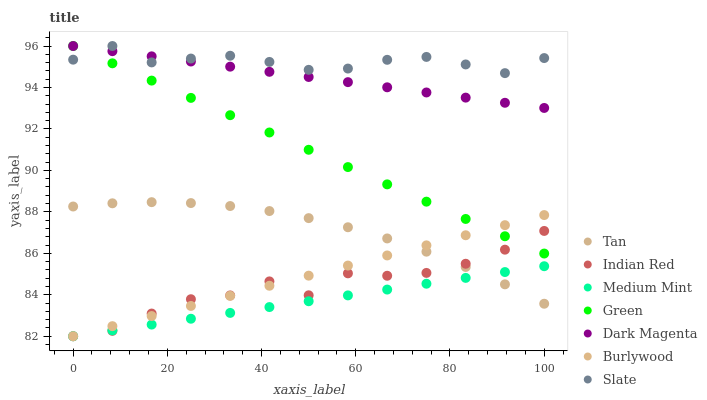Does Medium Mint have the minimum area under the curve?
Answer yes or no. Yes. Does Slate have the maximum area under the curve?
Answer yes or no. Yes. Does Dark Magenta have the minimum area under the curve?
Answer yes or no. No. Does Dark Magenta have the maximum area under the curve?
Answer yes or no. No. Is Medium Mint the smoothest?
Answer yes or no. Yes. Is Indian Red the roughest?
Answer yes or no. Yes. Is Dark Magenta the smoothest?
Answer yes or no. No. Is Dark Magenta the roughest?
Answer yes or no. No. Does Medium Mint have the lowest value?
Answer yes or no. Yes. Does Dark Magenta have the lowest value?
Answer yes or no. No. Does Green have the highest value?
Answer yes or no. Yes. Does Burlywood have the highest value?
Answer yes or no. No. Is Burlywood less than Slate?
Answer yes or no. Yes. Is Dark Magenta greater than Burlywood?
Answer yes or no. Yes. Does Medium Mint intersect Indian Red?
Answer yes or no. Yes. Is Medium Mint less than Indian Red?
Answer yes or no. No. Is Medium Mint greater than Indian Red?
Answer yes or no. No. Does Burlywood intersect Slate?
Answer yes or no. No. 